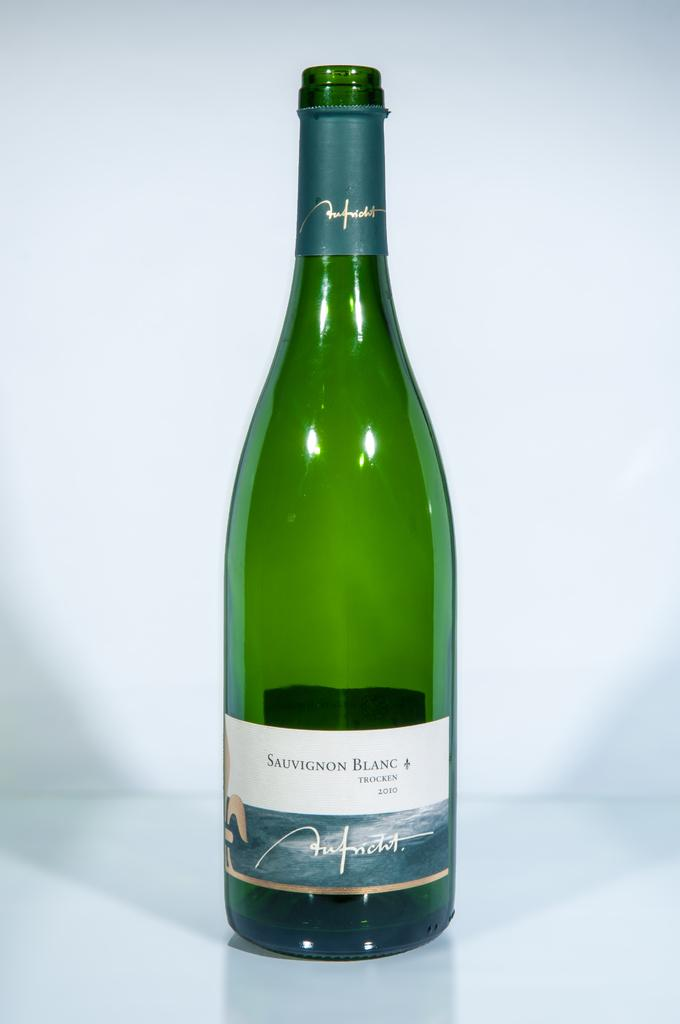What is the main object in the foreground of the image? There is a green colored bottle in the foreground of the image. What is the color of the surface on which the bottle is placed? The green colored bottle is on a white surface. What is the color of the background in the image? The background of the image is white. What type of form is the manager filling out in the image? There is no manager or form present in the image; it only features a green colored bottle on a white surface with a white background. 